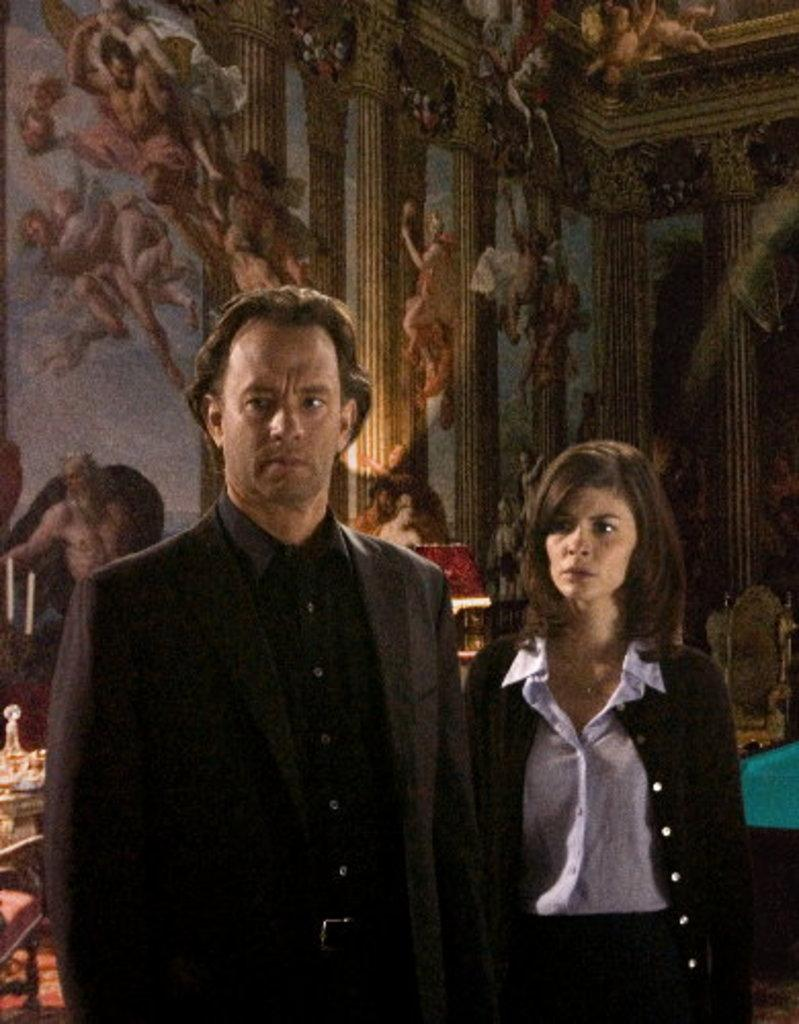How many people are present in the image? There are two people standing in the image. What can be seen on the wall in the image? There is a design on the wall. What type of furniture is visible in the image? There are chairs in the image. What else can be found on the floor in the image? There are other objects on the floor. Is there a maid cleaning the floor in the image? There is no maid present in the image, nor is there any indication of cleaning activities. 